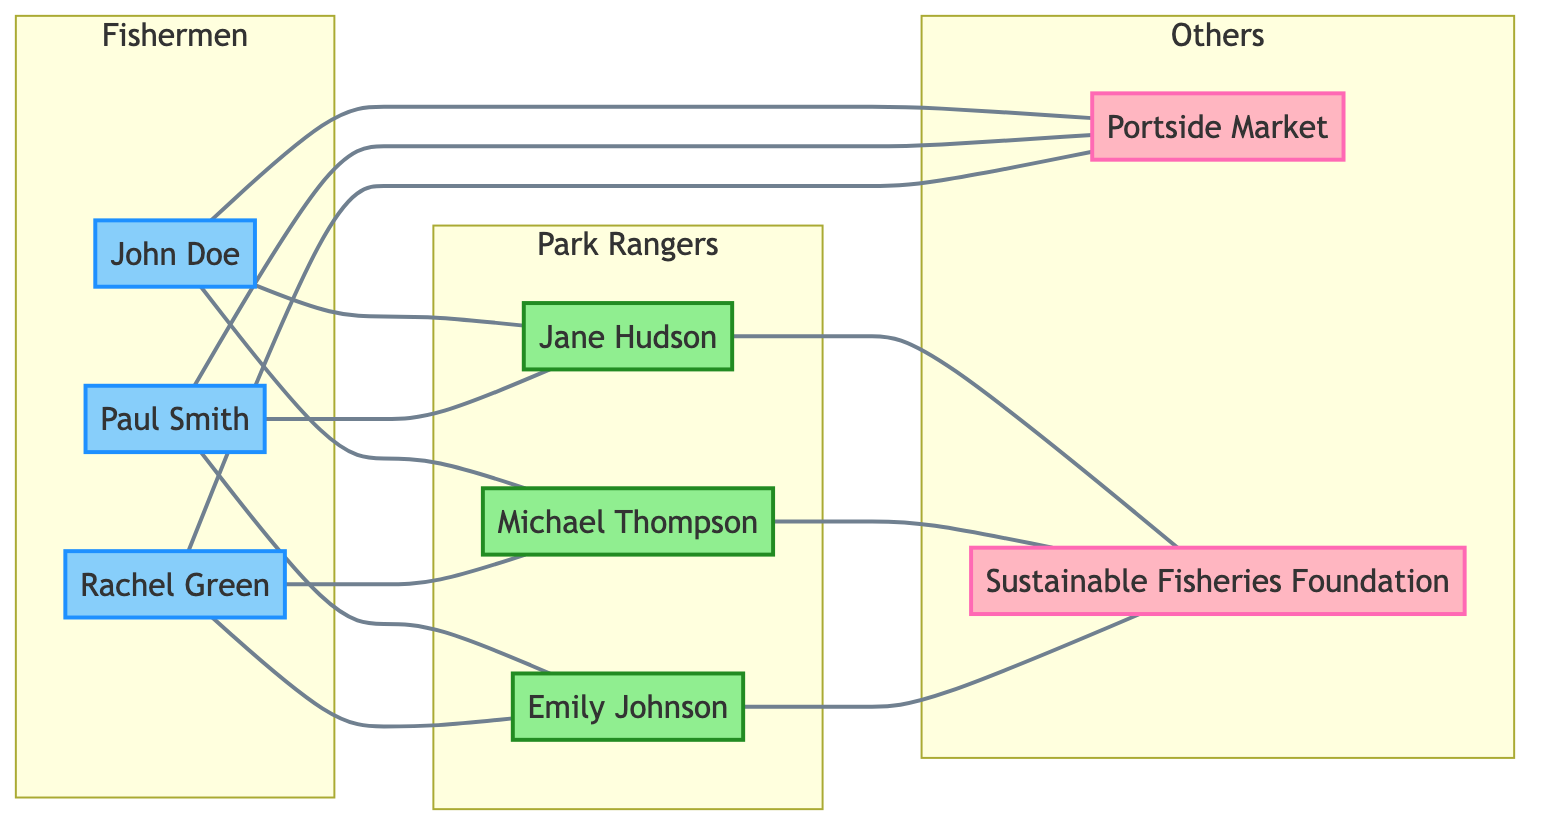What is the total number of fishermen in the diagram? There are three nodes representing fishermen: John Doe, Paul Smith, and Rachel Green. Counting them gives a total of three fishermen.
Answer: 3 Which park ranger is connected to both John Doe and Paul Smith? When looking at the edges connected to John Doe and Paul Smith, Jane Hudson is the only common park ranger connected to both fishermen.
Answer: Jane Hudson How many park rangers are there in total? The diagram lists three park rangers: Jane Hudson, Michael Thompson, and Emily Johnson. Counting these gives a total of three park rangers.
Answer: 3 What other network is directly connected to Portside Market? By reviewing the connections, all three fishermen (John Doe, Paul Smith, Rachel Green) are directly connected to Portside Market. Thus, the other entities are the fishermen themselves.
Answer: John Doe, Paul Smith, Rachel Green Which organizations do the park rangers collaborate with? All three park rangers (Jane Hudson, Michael Thompson, Emily Johnson) have connections to the Sustainable Fisheries Foundation, indicating this is the organization they collaborate with.
Answer: Sustainable Fisheries Foundation Which fisherman is connected to the most park rangers? John Doe and Rachel Green are each connected to two park rangers, while Paul Smith is connected to two different park rangers, so all three fishermen are equally connected.
Answer: John Doe, Paul Smith, Rachel Green Is there a fisherman who does not connect to a park ranger? Reviewing the edges shows that all three fishermen are connected to park rangers, meaning there are no fishermen disconnected from park rangers.
Answer: No Which park ranger is connected to the local market? When examining the edges, we can see that there are no park rangers directly connected to the local market; all connections to the local market stem from the fishermen.
Answer: None 